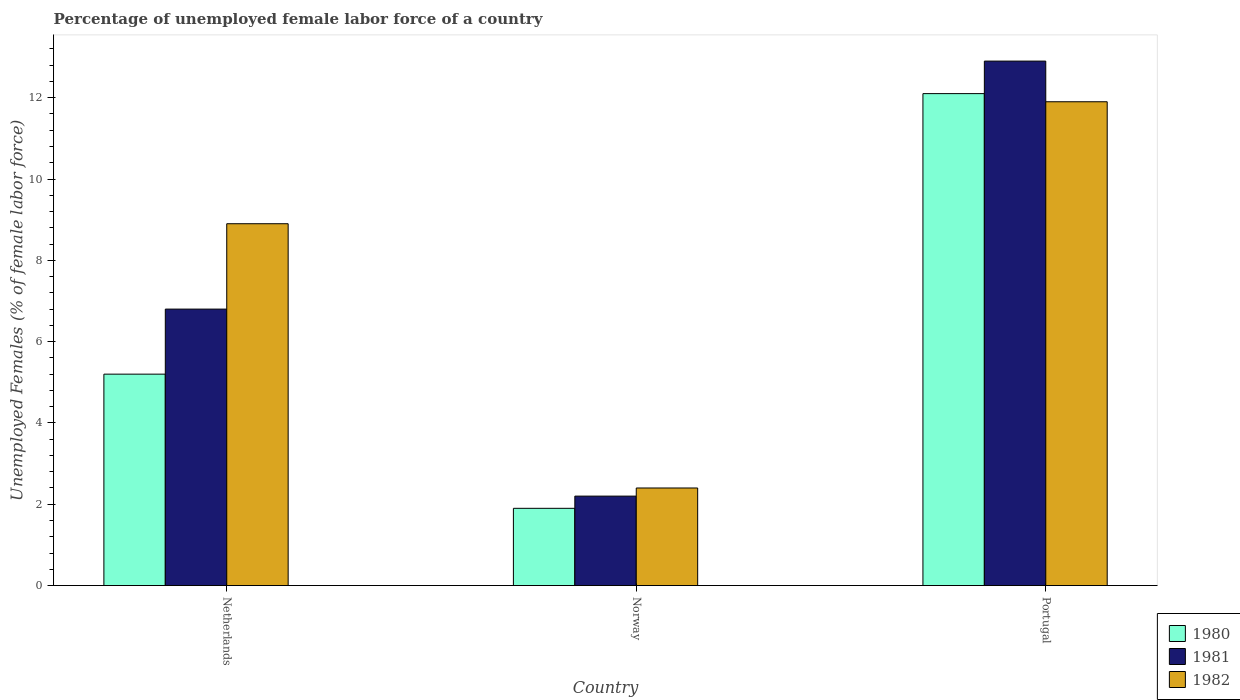How many groups of bars are there?
Your answer should be very brief. 3. How many bars are there on the 2nd tick from the right?
Offer a terse response. 3. What is the label of the 1st group of bars from the left?
Offer a very short reply. Netherlands. In how many cases, is the number of bars for a given country not equal to the number of legend labels?
Provide a succinct answer. 0. What is the percentage of unemployed female labor force in 1981 in Netherlands?
Provide a short and direct response. 6.8. Across all countries, what is the maximum percentage of unemployed female labor force in 1982?
Offer a terse response. 11.9. Across all countries, what is the minimum percentage of unemployed female labor force in 1980?
Your answer should be very brief. 1.9. In which country was the percentage of unemployed female labor force in 1982 maximum?
Make the answer very short. Portugal. What is the total percentage of unemployed female labor force in 1980 in the graph?
Provide a short and direct response. 19.2. What is the difference between the percentage of unemployed female labor force in 1980 in Netherlands and that in Portugal?
Your response must be concise. -6.9. What is the difference between the percentage of unemployed female labor force in 1980 in Portugal and the percentage of unemployed female labor force in 1982 in Norway?
Offer a very short reply. 9.7. What is the average percentage of unemployed female labor force in 1981 per country?
Offer a very short reply. 7.3. What is the difference between the percentage of unemployed female labor force of/in 1982 and percentage of unemployed female labor force of/in 1980 in Norway?
Offer a terse response. 0.5. In how many countries, is the percentage of unemployed female labor force in 1981 greater than 12 %?
Ensure brevity in your answer.  1. What is the ratio of the percentage of unemployed female labor force in 1980 in Netherlands to that in Portugal?
Provide a succinct answer. 0.43. Is the percentage of unemployed female labor force in 1980 in Netherlands less than that in Norway?
Keep it short and to the point. No. Is the difference between the percentage of unemployed female labor force in 1982 in Netherlands and Norway greater than the difference between the percentage of unemployed female labor force in 1980 in Netherlands and Norway?
Offer a terse response. Yes. What is the difference between the highest and the second highest percentage of unemployed female labor force in 1980?
Your answer should be compact. -10.2. What is the difference between the highest and the lowest percentage of unemployed female labor force in 1982?
Offer a terse response. 9.5. In how many countries, is the percentage of unemployed female labor force in 1981 greater than the average percentage of unemployed female labor force in 1981 taken over all countries?
Provide a short and direct response. 1. Is the sum of the percentage of unemployed female labor force in 1981 in Netherlands and Norway greater than the maximum percentage of unemployed female labor force in 1980 across all countries?
Provide a short and direct response. No. What does the 1st bar from the left in Norway represents?
Make the answer very short. 1980. What does the 3rd bar from the right in Netherlands represents?
Your answer should be very brief. 1980. How many bars are there?
Offer a very short reply. 9. Are all the bars in the graph horizontal?
Make the answer very short. No. How many countries are there in the graph?
Offer a terse response. 3. Does the graph contain any zero values?
Make the answer very short. No. Does the graph contain grids?
Your response must be concise. No. Where does the legend appear in the graph?
Offer a terse response. Bottom right. What is the title of the graph?
Make the answer very short. Percentage of unemployed female labor force of a country. What is the label or title of the X-axis?
Give a very brief answer. Country. What is the label or title of the Y-axis?
Make the answer very short. Unemployed Females (% of female labor force). What is the Unemployed Females (% of female labor force) of 1980 in Netherlands?
Offer a terse response. 5.2. What is the Unemployed Females (% of female labor force) in 1981 in Netherlands?
Ensure brevity in your answer.  6.8. What is the Unemployed Females (% of female labor force) in 1982 in Netherlands?
Offer a terse response. 8.9. What is the Unemployed Females (% of female labor force) of 1980 in Norway?
Provide a succinct answer. 1.9. What is the Unemployed Females (% of female labor force) in 1981 in Norway?
Your answer should be very brief. 2.2. What is the Unemployed Females (% of female labor force) of 1982 in Norway?
Provide a succinct answer. 2.4. What is the Unemployed Females (% of female labor force) of 1980 in Portugal?
Your answer should be compact. 12.1. What is the Unemployed Females (% of female labor force) in 1981 in Portugal?
Your answer should be very brief. 12.9. What is the Unemployed Females (% of female labor force) in 1982 in Portugal?
Keep it short and to the point. 11.9. Across all countries, what is the maximum Unemployed Females (% of female labor force) in 1980?
Your answer should be compact. 12.1. Across all countries, what is the maximum Unemployed Females (% of female labor force) in 1981?
Provide a succinct answer. 12.9. Across all countries, what is the maximum Unemployed Females (% of female labor force) of 1982?
Keep it short and to the point. 11.9. Across all countries, what is the minimum Unemployed Females (% of female labor force) of 1980?
Your response must be concise. 1.9. Across all countries, what is the minimum Unemployed Females (% of female labor force) of 1981?
Your response must be concise. 2.2. Across all countries, what is the minimum Unemployed Females (% of female labor force) of 1982?
Keep it short and to the point. 2.4. What is the total Unemployed Females (% of female labor force) of 1980 in the graph?
Make the answer very short. 19.2. What is the total Unemployed Females (% of female labor force) of 1981 in the graph?
Make the answer very short. 21.9. What is the total Unemployed Females (% of female labor force) of 1982 in the graph?
Offer a terse response. 23.2. What is the difference between the Unemployed Females (% of female labor force) in 1980 in Netherlands and that in Norway?
Your answer should be very brief. 3.3. What is the difference between the Unemployed Females (% of female labor force) of 1981 in Netherlands and that in Norway?
Offer a very short reply. 4.6. What is the difference between the Unemployed Females (% of female labor force) of 1980 in Netherlands and that in Portugal?
Provide a succinct answer. -6.9. What is the difference between the Unemployed Females (% of female labor force) of 1981 in Norway and that in Portugal?
Offer a terse response. -10.7. What is the difference between the Unemployed Females (% of female labor force) in 1981 in Netherlands and the Unemployed Females (% of female labor force) in 1982 in Norway?
Ensure brevity in your answer.  4.4. What is the difference between the Unemployed Females (% of female labor force) in 1981 in Netherlands and the Unemployed Females (% of female labor force) in 1982 in Portugal?
Make the answer very short. -5.1. What is the difference between the Unemployed Females (% of female labor force) of 1980 in Norway and the Unemployed Females (% of female labor force) of 1982 in Portugal?
Your answer should be very brief. -10. What is the average Unemployed Females (% of female labor force) of 1982 per country?
Make the answer very short. 7.73. What is the difference between the Unemployed Females (% of female labor force) of 1981 and Unemployed Females (% of female labor force) of 1982 in Netherlands?
Provide a short and direct response. -2.1. What is the difference between the Unemployed Females (% of female labor force) in 1981 and Unemployed Females (% of female labor force) in 1982 in Norway?
Provide a succinct answer. -0.2. What is the difference between the Unemployed Females (% of female labor force) of 1980 and Unemployed Females (% of female labor force) of 1981 in Portugal?
Offer a terse response. -0.8. What is the difference between the Unemployed Females (% of female labor force) in 1980 and Unemployed Females (% of female labor force) in 1982 in Portugal?
Your response must be concise. 0.2. What is the ratio of the Unemployed Females (% of female labor force) in 1980 in Netherlands to that in Norway?
Ensure brevity in your answer.  2.74. What is the ratio of the Unemployed Females (% of female labor force) of 1981 in Netherlands to that in Norway?
Offer a very short reply. 3.09. What is the ratio of the Unemployed Females (% of female labor force) of 1982 in Netherlands to that in Norway?
Offer a very short reply. 3.71. What is the ratio of the Unemployed Females (% of female labor force) of 1980 in Netherlands to that in Portugal?
Offer a terse response. 0.43. What is the ratio of the Unemployed Females (% of female labor force) of 1981 in Netherlands to that in Portugal?
Keep it short and to the point. 0.53. What is the ratio of the Unemployed Females (% of female labor force) of 1982 in Netherlands to that in Portugal?
Offer a terse response. 0.75. What is the ratio of the Unemployed Females (% of female labor force) of 1980 in Norway to that in Portugal?
Offer a very short reply. 0.16. What is the ratio of the Unemployed Females (% of female labor force) of 1981 in Norway to that in Portugal?
Offer a very short reply. 0.17. What is the ratio of the Unemployed Females (% of female labor force) of 1982 in Norway to that in Portugal?
Your answer should be compact. 0.2. What is the difference between the highest and the second highest Unemployed Females (% of female labor force) of 1980?
Give a very brief answer. 6.9. What is the difference between the highest and the second highest Unemployed Females (% of female labor force) of 1982?
Ensure brevity in your answer.  3. What is the difference between the highest and the lowest Unemployed Females (% of female labor force) in 1980?
Your answer should be compact. 10.2. What is the difference between the highest and the lowest Unemployed Females (% of female labor force) in 1982?
Your answer should be compact. 9.5. 